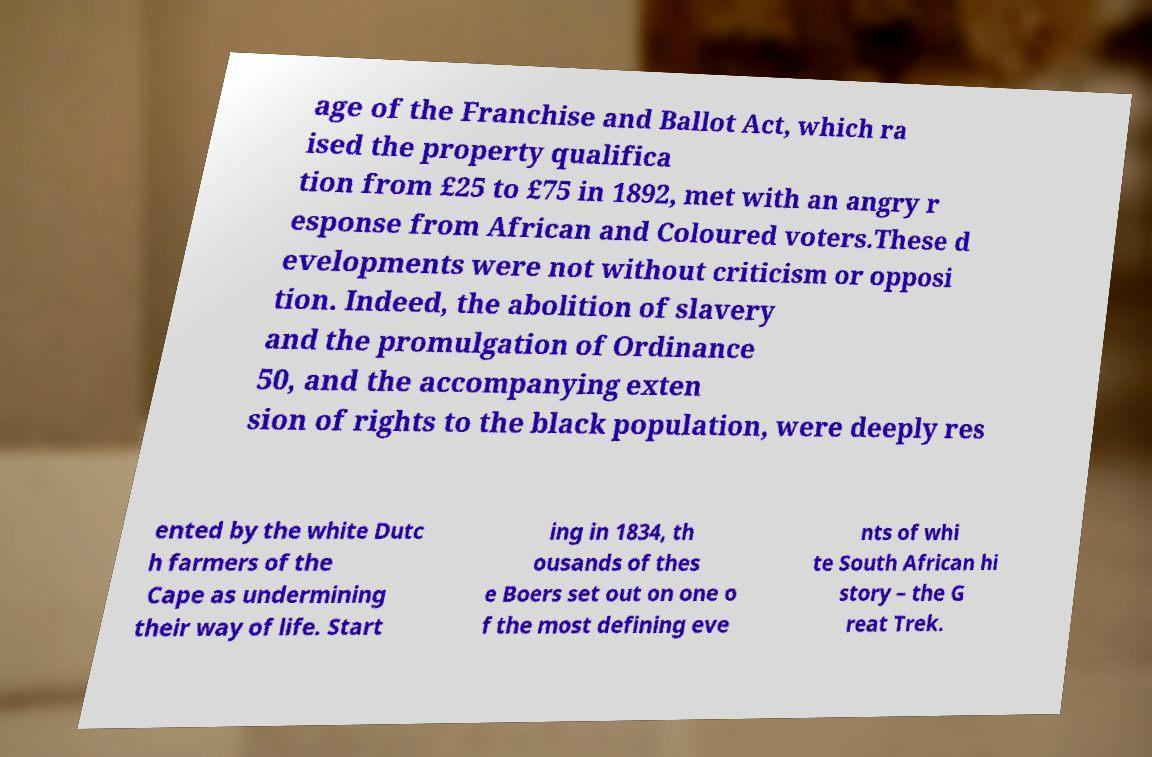What messages or text are displayed in this image? I need them in a readable, typed format. age of the Franchise and Ballot Act, which ra ised the property qualifica tion from £25 to £75 in 1892, met with an angry r esponse from African and Coloured voters.These d evelopments were not without criticism or opposi tion. Indeed, the abolition of slavery and the promulgation of Ordinance 50, and the accompanying exten sion of rights to the black population, were deeply res ented by the white Dutc h farmers of the Cape as undermining their way of life. Start ing in 1834, th ousands of thes e Boers set out on one o f the most defining eve nts of whi te South African hi story – the G reat Trek. 